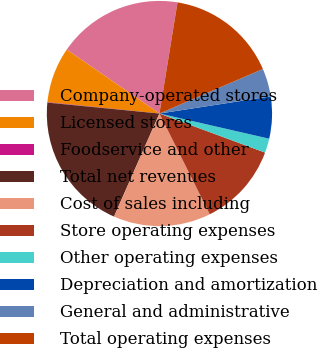Convert chart. <chart><loc_0><loc_0><loc_500><loc_500><pie_chart><fcel>Company-operated stores<fcel>Licensed stores<fcel>Foodservice and other<fcel>Total net revenues<fcel>Cost of sales including<fcel>Store operating expenses<fcel>Other operating expenses<fcel>Depreciation and amortization<fcel>General and administrative<fcel>Total operating expenses<nl><fcel>17.95%<fcel>8.01%<fcel>0.06%<fcel>19.94%<fcel>13.98%<fcel>11.99%<fcel>2.05%<fcel>6.02%<fcel>4.04%<fcel>15.96%<nl></chart> 